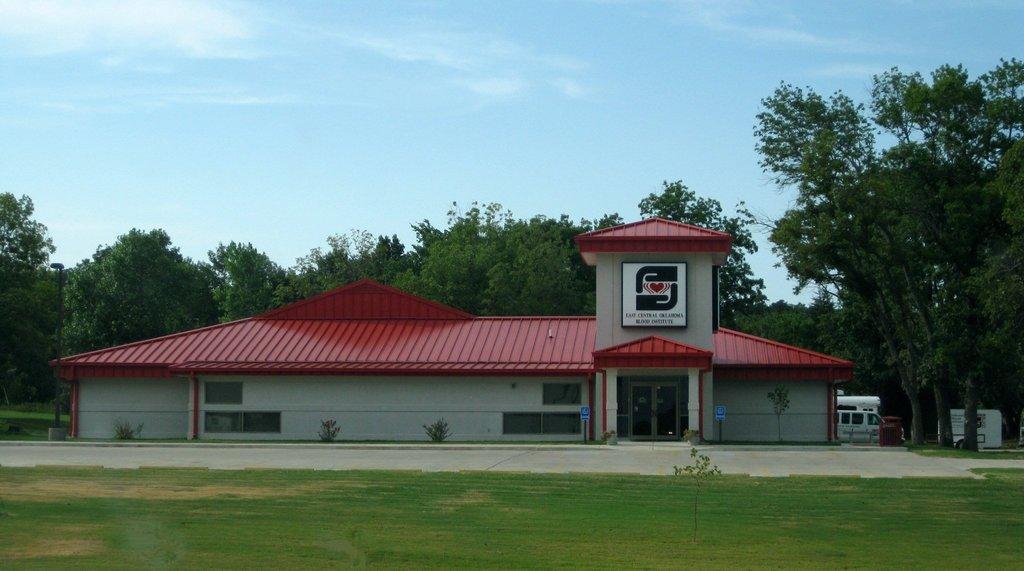How would you summarize this image in a sentence or two? At the bottom of this image, there is grass on the ground. In the background, there is a building having windows and doors, there are trees, vehicles and there are clouds in the sky. 